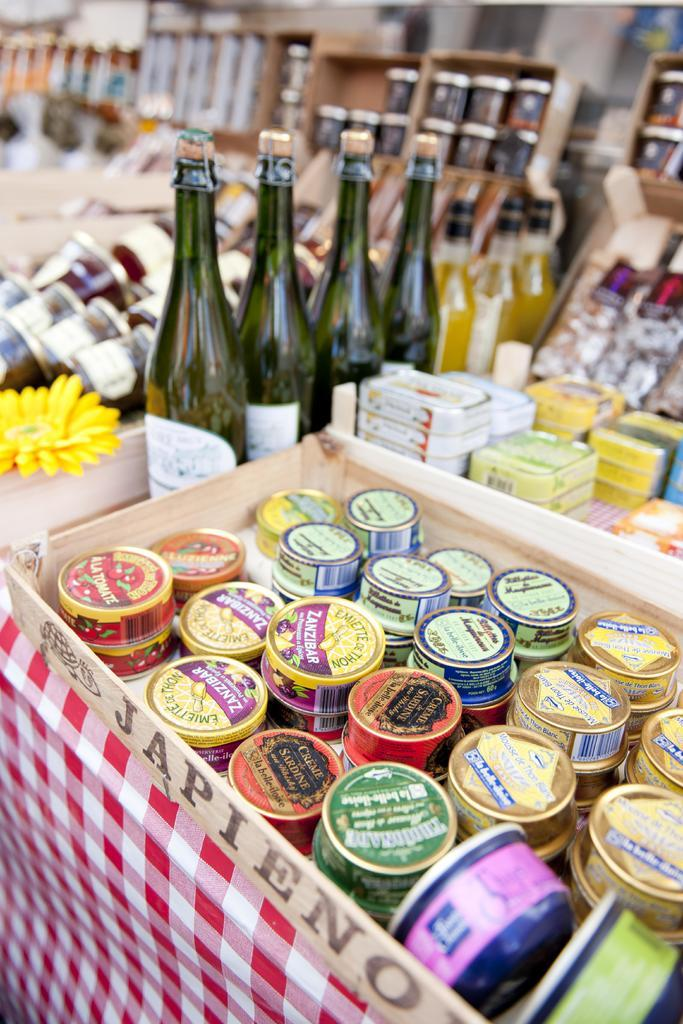<image>
Share a concise interpretation of the image provided. The circular containers sit in a box labeled "JAPIENO." 